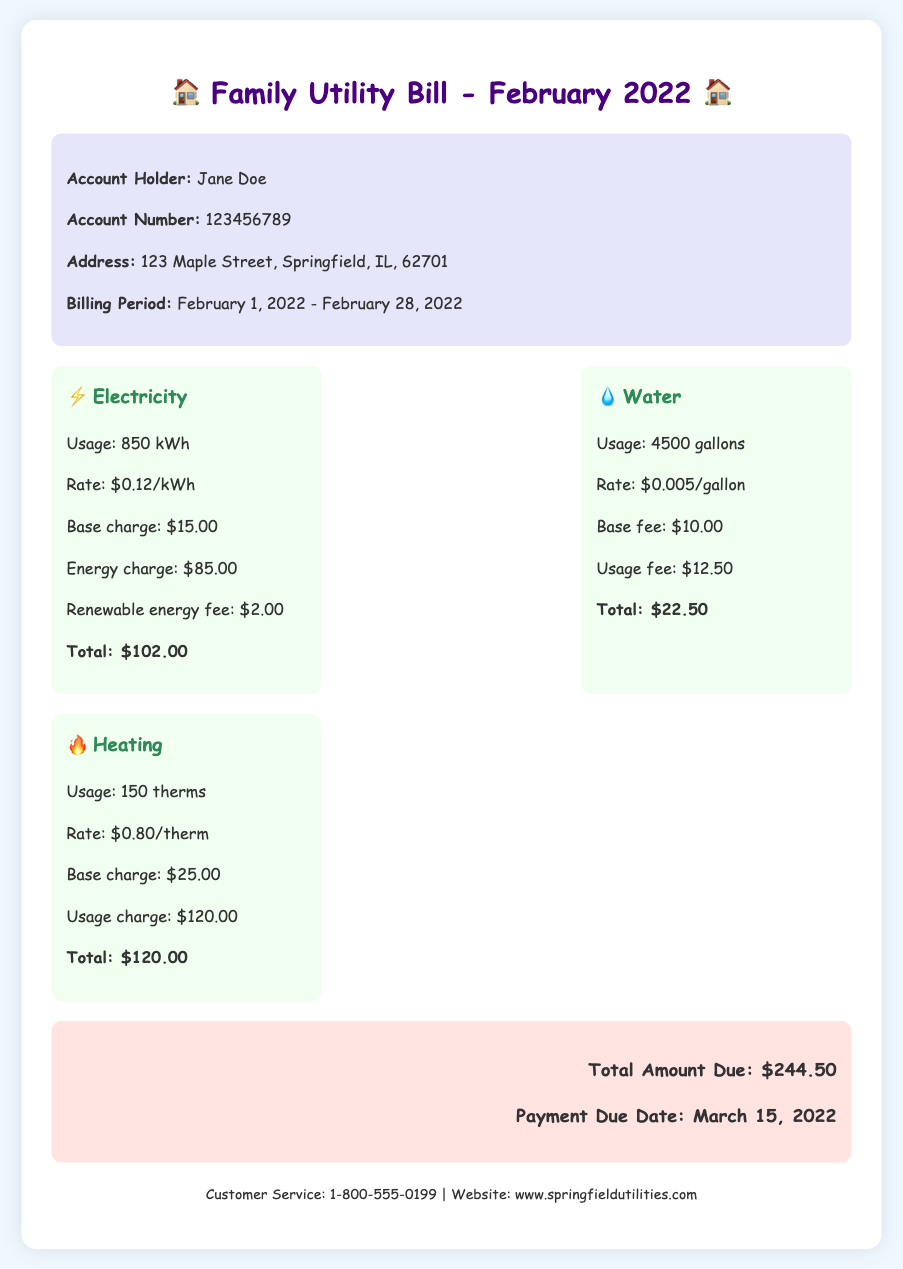What is the billing period? The billing period is the duration for which the services were billed, which is February 1, 2022 - February 28, 2022.
Answer: February 1, 2022 - February 28, 2022 Who is the account holder? The account holder is the person whose name appears on the bill, which in this case is Jane Doe.
Answer: Jane Doe What is the total amount due? The total amount due is the sum of the electricity, water, and heating charges listed in the document, which is $244.50.
Answer: $244.50 How much is the renewable energy fee? The renewable energy fee is a specific charge included in the electricity breakdown. It is stated clearly in the document as $2.00.
Answer: $2.00 What is the usage of water? The usage of water refers to the amount of water consumed during the billing period, indicated as 4500 gallons.
Answer: 4500 gallons What is the base charge for heating? The base charge for heating is provided within the heating section of the bill, specified as $25.00.
Answer: $25.00 How many therms were used for heating? The document indicates that the usage for heating is counted in therms, specifically stating the number used as 150 therms.
Answer: 150 therms When is the payment due date? The payment due date is when the total amount must be paid, which is noted as March 15, 2022.
Answer: March 15, 2022 What is the rate for electricity per kWh? The electricity rate is the cost per unit of electricity used, clearly stated in the document as $0.12/kWh.
Answer: $0.12/kWh 